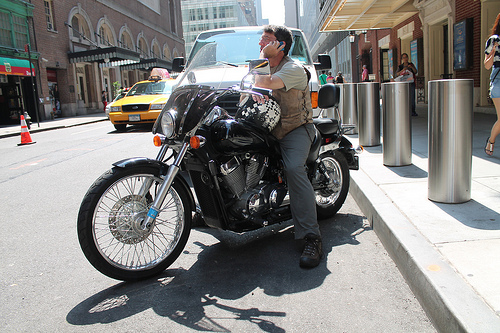Is the woman to the left or to the right of the motorcycle? The woman is to the right of the motorcycle, although only partially visible in the frame. 